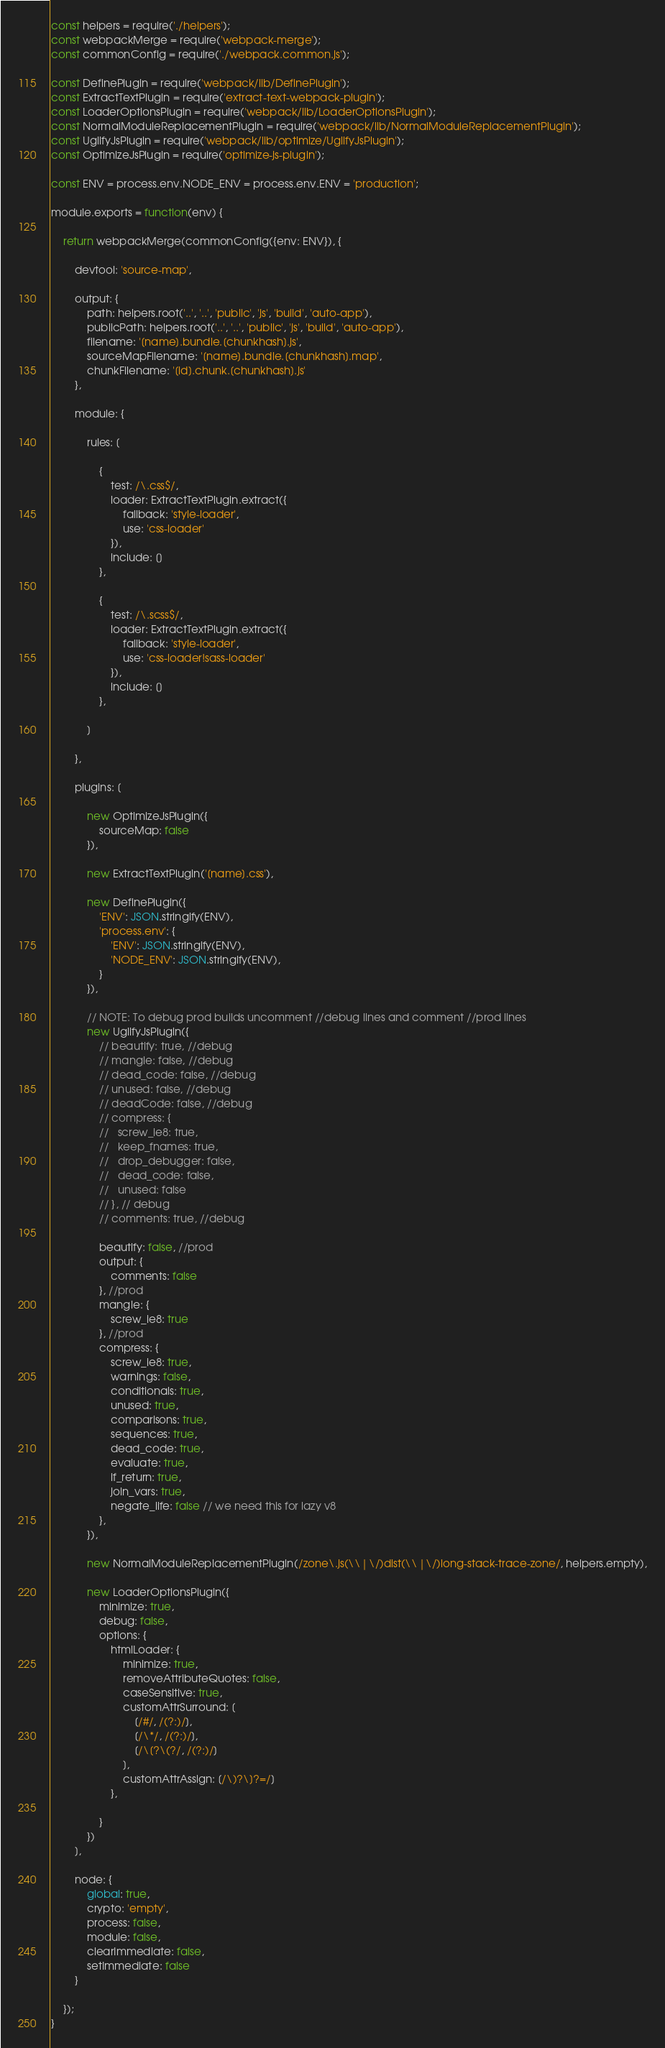Convert code to text. <code><loc_0><loc_0><loc_500><loc_500><_JavaScript_>const helpers = require('./helpers');
const webpackMerge = require('webpack-merge');
const commonConfig = require('./webpack.common.js');

const DefinePlugin = require('webpack/lib/DefinePlugin');
const ExtractTextPlugin = require('extract-text-webpack-plugin');
const LoaderOptionsPlugin = require('webpack/lib/LoaderOptionsPlugin');
const NormalModuleReplacementPlugin = require('webpack/lib/NormalModuleReplacementPlugin');
const UglifyJsPlugin = require('webpack/lib/optimize/UglifyJsPlugin');
const OptimizeJsPlugin = require('optimize-js-plugin');

const ENV = process.env.NODE_ENV = process.env.ENV = 'production';

module.exports = function(env) {

    return webpackMerge(commonConfig({env: ENV}), {

        devtool: 'source-map',

        output: {
            path: helpers.root('..', '..', 'public', 'js', 'build', 'auto-app'),
            publicPath: helpers.root('..', '..', 'public', 'js', 'build', 'auto-app'),
            filename: '[name].bundle.[chunkhash].js',
            sourceMapFilename: '[name].bundle.[chunkhash].map',
            chunkFilename: '[id].chunk.[chunkhash].js'
        },

        module: {

            rules: [

                {
                    test: /\.css$/,
                    loader: ExtractTextPlugin.extract({
                        fallback: 'style-loader',
                        use: 'css-loader'
                    }),
                    include: []
                },

                {
                    test: /\.scss$/,
                    loader: ExtractTextPlugin.extract({
                        fallback: 'style-loader',
                        use: 'css-loader!sass-loader'
                    }),
                    include: []
                },

            ]

        },

        plugins: [

            new OptimizeJsPlugin({
                sourceMap: false
            }),

            new ExtractTextPlugin('[name].css'),

            new DefinePlugin({
                'ENV': JSON.stringify(ENV),
                'process.env': {
                    'ENV': JSON.stringify(ENV),
                    'NODE_ENV': JSON.stringify(ENV),
                }
            }),

            // NOTE: To debug prod builds uncomment //debug lines and comment //prod lines
            new UglifyJsPlugin({
                // beautify: true, //debug
                // mangle: false, //debug
                // dead_code: false, //debug
                // unused: false, //debug
                // deadCode: false, //debug
                // compress: {
                //   screw_ie8: true,
                //   keep_fnames: true,
                //   drop_debugger: false,
                //   dead_code: false,
                //   unused: false
                // }, // debug
                // comments: true, //debug

                beautify: false, //prod
                output: {
                    comments: false
                }, //prod
                mangle: {
                    screw_ie8: true
                }, //prod
                compress: {
                    screw_ie8: true,
                    warnings: false,
                    conditionals: true,
                    unused: true,
                    comparisons: true,
                    sequences: true,
                    dead_code: true,
                    evaluate: true,
                    if_return: true,
                    join_vars: true,
                    negate_iife: false // we need this for lazy v8
                },
            }),

            new NormalModuleReplacementPlugin(/zone\.js(\\|\/)dist(\\|\/)long-stack-trace-zone/, helpers.empty),

            new LoaderOptionsPlugin({
                minimize: true,
                debug: false,
                options: {
                    htmlLoader: {
                        minimize: true,
                        removeAttributeQuotes: false,
                        caseSensitive: true,
                        customAttrSurround: [
                            [/#/, /(?:)/],
                            [/\*/, /(?:)/],
                            [/\[?\(?/, /(?:)/]
                        ],
                        customAttrAssign: [/\)?\]?=/]
                    },

                }
            })
        ],

        node: {
            global: true,
            crypto: 'empty',
            process: false,
            module: false,
            clearImmediate: false,
            setImmediate: false
        }

    });
}</code> 